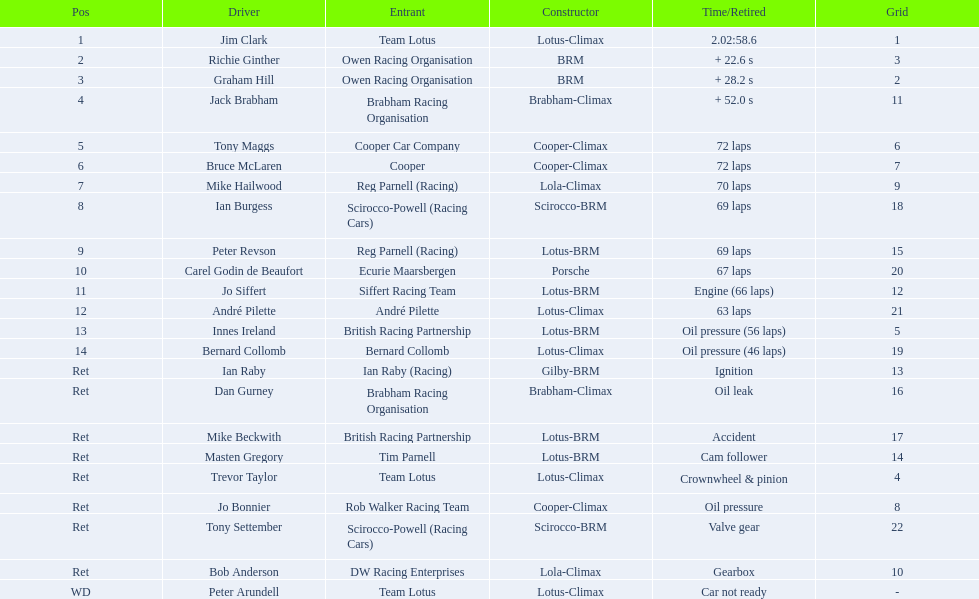Who are all the racers? Jim Clark, Richie Ginther, Graham Hill, Jack Brabham, Tony Maggs, Bruce McLaren, Mike Hailwood, Ian Burgess, Peter Revson, Carel Godin de Beaufort, Jo Siffert, André Pilette, Innes Ireland, Bernard Collomb, Ian Raby, Dan Gurney, Mike Beckwith, Masten Gregory, Trevor Taylor, Jo Bonnier, Tony Settember, Bob Anderson, Peter Arundell. What place did they hold? 1, 2, 3, 4, 5, 6, 7, 8, 9, 10, 11, 12, 13, 14, Ret, Ret, Ret, Ret, Ret, Ret, Ret, Ret, WD. What about only tony maggs and jo siffert? 5, 11. And between them, which driver arrived sooner? Tony Maggs. 